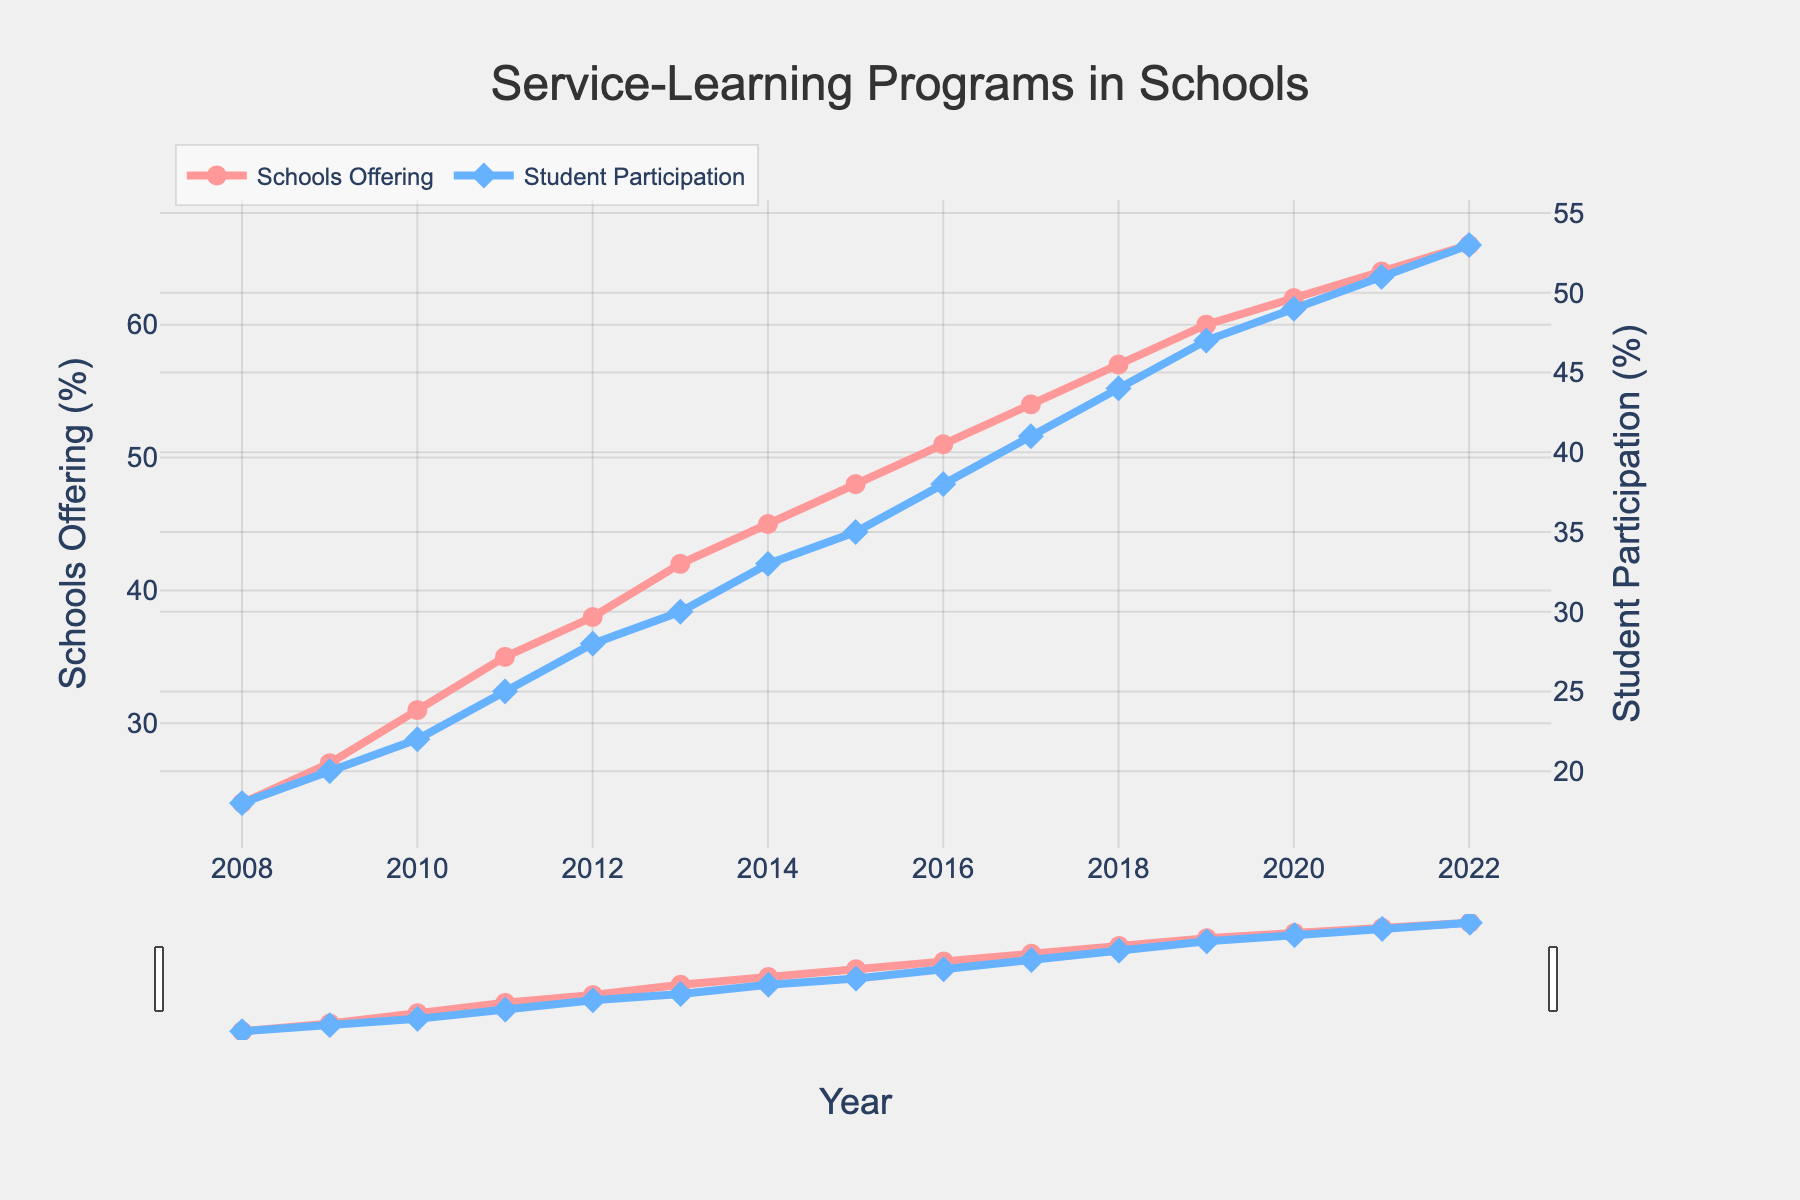Which year saw the highest percentage of schools offering service-learning programs? The year with the highest percentage can be identified by looking at the last point on the Schools Offering (%) line.
Answer: 2022 Which year had the lowest student participation rate in service-learning programs? The year with the lowest student participation is the first point on the Student Participation (%) line.
Answer: 2008 By how many percentage points did student participation increase from 2008 to 2022? Find the values for student participation in 2008 and 2022, then subtract the 2008 value from the 2022 value: 53% - 18% = 35%.
Answer: 35% Compare the overall trend of schools offering service-learning programs to student participation rates. Both lines show an increasing trend from 2008 to 2022, indicating a positive correlation between the percentage of schools offering programs and student participation rates.
Answer: Both increasing Which year experienced the largest one-year increase in student participation rates? Identify the year with the largest vertical jump between consecutive points on the Student Participation (%) line. This can be seen between 2018 and 2019, where it increased by 3% (47% - 44%).
Answer: 2019 What is the average student participation percentage from 2008 to 2022? Sum all the student participation percentages and divide by the number of years: (18 + 20 + 22 + 25 + 28 + 30 + 33 + 35 + 38 + 41 + 44 + 47 + 49 + 51 + 53) / 15 ≈ 35.73%.
Answer: 35.73% Was there any year between 2008 and 2022 when the percentage of schools offering programs did not increase? Check the line for schools offering programs; it shows a consistent upward trend every year with no declines.
Answer: No In which year was the difference between the percentage of schools offering programs and student participation the greatest? Calculate the difference for each year and identify the year with the largest difference. This occurs in 2008 with a difference of (24% - 18%) = 6%.
Answer: 2008 How do the visual markers differ for the two lines representing schools offering programs and student participation? The Schools Offering (%) line uses circular markers, and the Student Participation (%) line uses diamond-shaped markers, and both lines have different colors (red for schools, blue for students).
Answer: Different shapes and colors What is the percentage point increase in the number of schools offering service-learning programs from 2015 to 2016? Subtract the 2015 value from the 2016 value: 51% - 48% = 3%.
Answer: 3% 